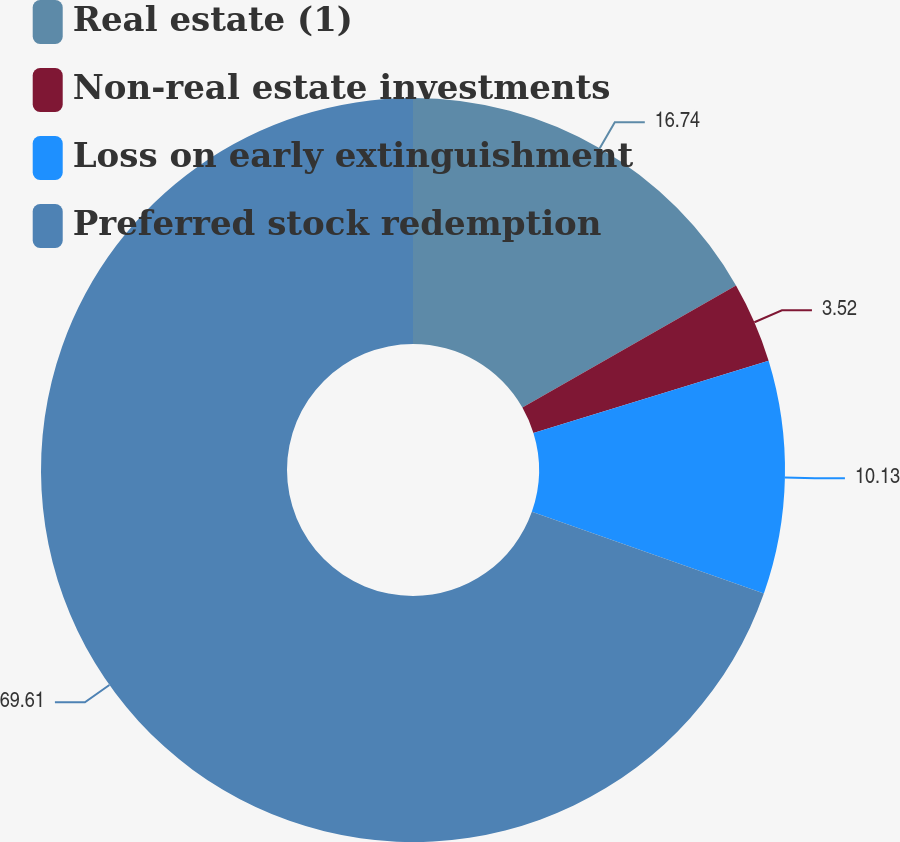<chart> <loc_0><loc_0><loc_500><loc_500><pie_chart><fcel>Real estate (1)<fcel>Non-real estate investments<fcel>Loss on early extinguishment<fcel>Preferred stock redemption<nl><fcel>16.74%<fcel>3.52%<fcel>10.13%<fcel>69.61%<nl></chart> 